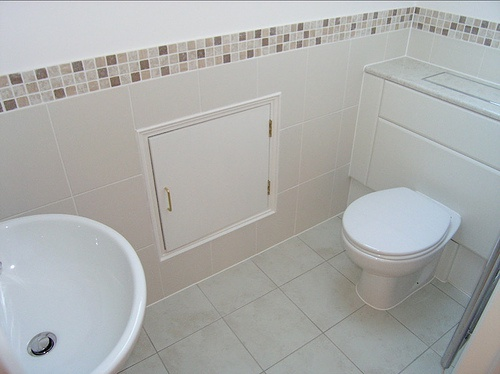Describe the objects in this image and their specific colors. I can see sink in gray, lightgray, and darkgray tones and toilet in gray, darkgray, and lightgray tones in this image. 